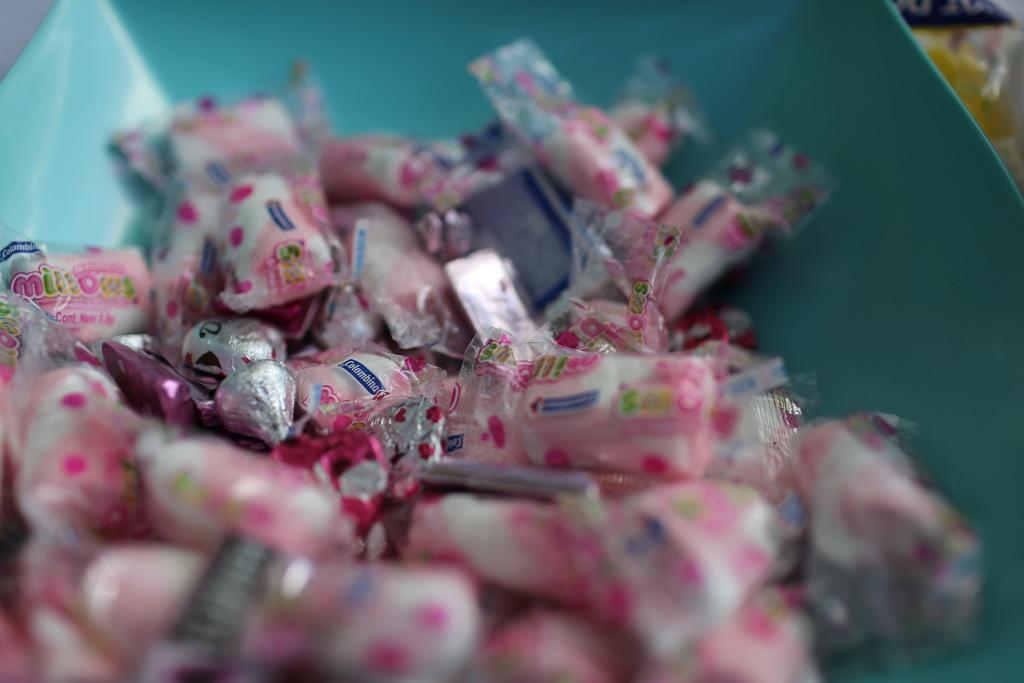What type of candy is depicted in the image? The image contains chocolates covers. Where are the chocolates covers located in the image? The chocolates covers are at the bottom of the image. What type of sound can be heard coming from the chocolates covers in the image? There is no sound coming from the chocolates covers in the image. What letters are written on the chocolates covers in the image? There are no letters written on the chocolates covers in the image. 